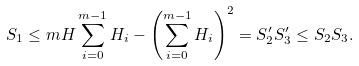Convert formula to latex. <formula><loc_0><loc_0><loc_500><loc_500>S _ { 1 } \leq m H \sum _ { i = 0 } ^ { m - 1 } H _ { i } - \left ( \sum _ { i = 0 } ^ { m - 1 } H _ { i } \right ) ^ { 2 } = S _ { 2 } ^ { \prime } S _ { 3 } ^ { \prime } \leq S _ { 2 } S _ { 3 } .</formula> 